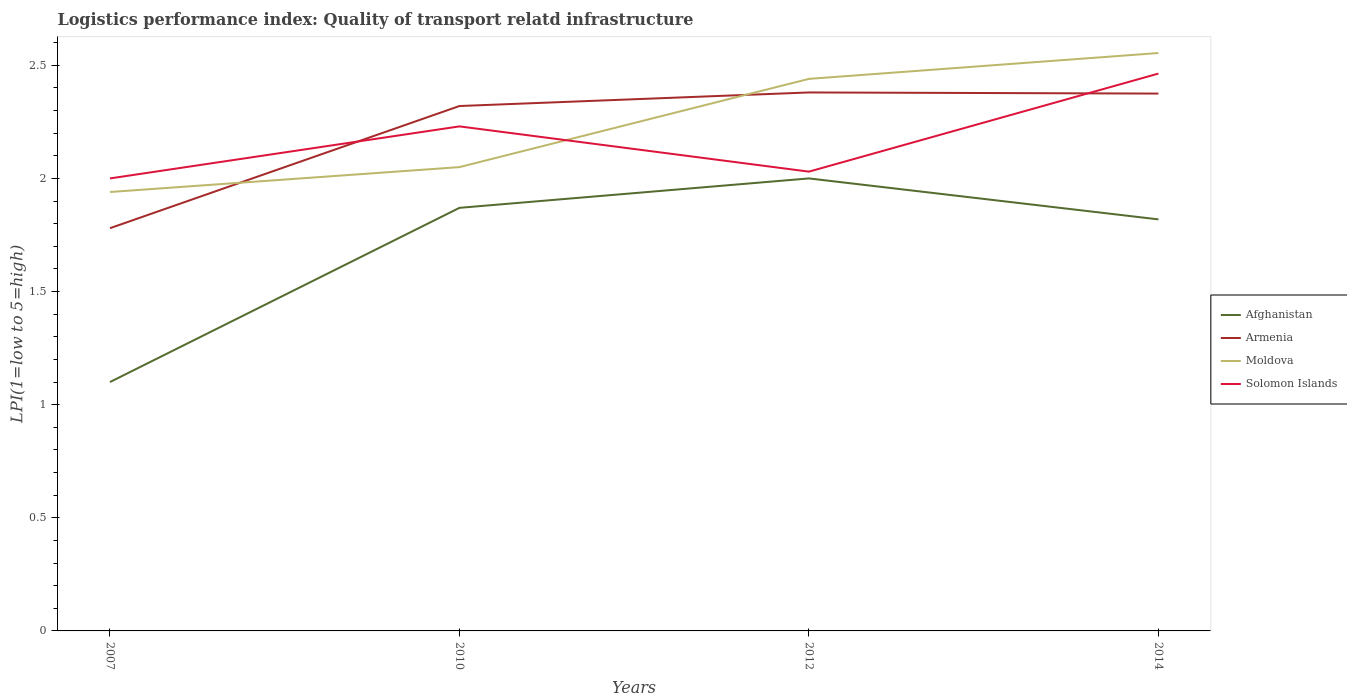Does the line corresponding to Armenia intersect with the line corresponding to Solomon Islands?
Your answer should be compact. Yes. Is the number of lines equal to the number of legend labels?
Give a very brief answer. Yes. In which year was the logistics performance index in Solomon Islands maximum?
Make the answer very short. 2007. What is the total logistics performance index in Moldova in the graph?
Your answer should be compact. -0.5. What is the difference between the highest and the second highest logistics performance index in Armenia?
Provide a succinct answer. 0.6. Is the logistics performance index in Armenia strictly greater than the logistics performance index in Afghanistan over the years?
Your answer should be very brief. No. How many lines are there?
Make the answer very short. 4. What is the difference between two consecutive major ticks on the Y-axis?
Offer a terse response. 0.5. Does the graph contain any zero values?
Give a very brief answer. No. Does the graph contain grids?
Ensure brevity in your answer.  No. Where does the legend appear in the graph?
Offer a terse response. Center right. How many legend labels are there?
Provide a short and direct response. 4. What is the title of the graph?
Offer a very short reply. Logistics performance index: Quality of transport relatd infrastructure. What is the label or title of the X-axis?
Your response must be concise. Years. What is the label or title of the Y-axis?
Make the answer very short. LPI(1=low to 5=high). What is the LPI(1=low to 5=high) of Afghanistan in 2007?
Make the answer very short. 1.1. What is the LPI(1=low to 5=high) in Armenia in 2007?
Your answer should be compact. 1.78. What is the LPI(1=low to 5=high) in Moldova in 2007?
Offer a terse response. 1.94. What is the LPI(1=low to 5=high) in Solomon Islands in 2007?
Your response must be concise. 2. What is the LPI(1=low to 5=high) in Afghanistan in 2010?
Provide a short and direct response. 1.87. What is the LPI(1=low to 5=high) in Armenia in 2010?
Your answer should be compact. 2.32. What is the LPI(1=low to 5=high) in Moldova in 2010?
Give a very brief answer. 2.05. What is the LPI(1=low to 5=high) of Solomon Islands in 2010?
Your answer should be very brief. 2.23. What is the LPI(1=low to 5=high) of Armenia in 2012?
Give a very brief answer. 2.38. What is the LPI(1=low to 5=high) of Moldova in 2012?
Ensure brevity in your answer.  2.44. What is the LPI(1=low to 5=high) of Solomon Islands in 2012?
Provide a short and direct response. 2.03. What is the LPI(1=low to 5=high) of Afghanistan in 2014?
Provide a short and direct response. 1.82. What is the LPI(1=low to 5=high) in Armenia in 2014?
Your answer should be compact. 2.38. What is the LPI(1=low to 5=high) in Moldova in 2014?
Offer a terse response. 2.55. What is the LPI(1=low to 5=high) of Solomon Islands in 2014?
Give a very brief answer. 2.46. Across all years, what is the maximum LPI(1=low to 5=high) of Afghanistan?
Make the answer very short. 2. Across all years, what is the maximum LPI(1=low to 5=high) of Armenia?
Provide a succinct answer. 2.38. Across all years, what is the maximum LPI(1=low to 5=high) of Moldova?
Your answer should be compact. 2.55. Across all years, what is the maximum LPI(1=low to 5=high) of Solomon Islands?
Provide a short and direct response. 2.46. Across all years, what is the minimum LPI(1=low to 5=high) of Afghanistan?
Provide a short and direct response. 1.1. Across all years, what is the minimum LPI(1=low to 5=high) in Armenia?
Offer a terse response. 1.78. Across all years, what is the minimum LPI(1=low to 5=high) of Moldova?
Your answer should be compact. 1.94. Across all years, what is the minimum LPI(1=low to 5=high) of Solomon Islands?
Give a very brief answer. 2. What is the total LPI(1=low to 5=high) of Afghanistan in the graph?
Provide a short and direct response. 6.79. What is the total LPI(1=low to 5=high) of Armenia in the graph?
Offer a terse response. 8.86. What is the total LPI(1=low to 5=high) of Moldova in the graph?
Keep it short and to the point. 8.98. What is the total LPI(1=low to 5=high) of Solomon Islands in the graph?
Offer a terse response. 8.72. What is the difference between the LPI(1=low to 5=high) of Afghanistan in 2007 and that in 2010?
Make the answer very short. -0.77. What is the difference between the LPI(1=low to 5=high) of Armenia in 2007 and that in 2010?
Offer a terse response. -0.54. What is the difference between the LPI(1=low to 5=high) in Moldova in 2007 and that in 2010?
Provide a succinct answer. -0.11. What is the difference between the LPI(1=low to 5=high) in Solomon Islands in 2007 and that in 2010?
Offer a terse response. -0.23. What is the difference between the LPI(1=low to 5=high) in Afghanistan in 2007 and that in 2012?
Offer a terse response. -0.9. What is the difference between the LPI(1=low to 5=high) of Armenia in 2007 and that in 2012?
Ensure brevity in your answer.  -0.6. What is the difference between the LPI(1=low to 5=high) in Solomon Islands in 2007 and that in 2012?
Provide a succinct answer. -0.03. What is the difference between the LPI(1=low to 5=high) in Afghanistan in 2007 and that in 2014?
Make the answer very short. -0.72. What is the difference between the LPI(1=low to 5=high) of Armenia in 2007 and that in 2014?
Keep it short and to the point. -0.59. What is the difference between the LPI(1=low to 5=high) in Moldova in 2007 and that in 2014?
Give a very brief answer. -0.61. What is the difference between the LPI(1=low to 5=high) in Solomon Islands in 2007 and that in 2014?
Provide a succinct answer. -0.46. What is the difference between the LPI(1=low to 5=high) in Afghanistan in 2010 and that in 2012?
Provide a short and direct response. -0.13. What is the difference between the LPI(1=low to 5=high) in Armenia in 2010 and that in 2012?
Your response must be concise. -0.06. What is the difference between the LPI(1=low to 5=high) in Moldova in 2010 and that in 2012?
Give a very brief answer. -0.39. What is the difference between the LPI(1=low to 5=high) in Afghanistan in 2010 and that in 2014?
Offer a very short reply. 0.05. What is the difference between the LPI(1=low to 5=high) in Armenia in 2010 and that in 2014?
Provide a short and direct response. -0.06. What is the difference between the LPI(1=low to 5=high) of Moldova in 2010 and that in 2014?
Keep it short and to the point. -0.5. What is the difference between the LPI(1=low to 5=high) in Solomon Islands in 2010 and that in 2014?
Keep it short and to the point. -0.23. What is the difference between the LPI(1=low to 5=high) in Afghanistan in 2012 and that in 2014?
Your answer should be compact. 0.18. What is the difference between the LPI(1=low to 5=high) of Armenia in 2012 and that in 2014?
Keep it short and to the point. 0.01. What is the difference between the LPI(1=low to 5=high) in Moldova in 2012 and that in 2014?
Provide a succinct answer. -0.11. What is the difference between the LPI(1=low to 5=high) of Solomon Islands in 2012 and that in 2014?
Your answer should be compact. -0.43. What is the difference between the LPI(1=low to 5=high) in Afghanistan in 2007 and the LPI(1=low to 5=high) in Armenia in 2010?
Make the answer very short. -1.22. What is the difference between the LPI(1=low to 5=high) of Afghanistan in 2007 and the LPI(1=low to 5=high) of Moldova in 2010?
Give a very brief answer. -0.95. What is the difference between the LPI(1=low to 5=high) of Afghanistan in 2007 and the LPI(1=low to 5=high) of Solomon Islands in 2010?
Your answer should be compact. -1.13. What is the difference between the LPI(1=low to 5=high) of Armenia in 2007 and the LPI(1=low to 5=high) of Moldova in 2010?
Ensure brevity in your answer.  -0.27. What is the difference between the LPI(1=low to 5=high) in Armenia in 2007 and the LPI(1=low to 5=high) in Solomon Islands in 2010?
Your response must be concise. -0.45. What is the difference between the LPI(1=low to 5=high) in Moldova in 2007 and the LPI(1=low to 5=high) in Solomon Islands in 2010?
Your answer should be very brief. -0.29. What is the difference between the LPI(1=low to 5=high) of Afghanistan in 2007 and the LPI(1=low to 5=high) of Armenia in 2012?
Offer a terse response. -1.28. What is the difference between the LPI(1=low to 5=high) of Afghanistan in 2007 and the LPI(1=low to 5=high) of Moldova in 2012?
Offer a terse response. -1.34. What is the difference between the LPI(1=low to 5=high) in Afghanistan in 2007 and the LPI(1=low to 5=high) in Solomon Islands in 2012?
Offer a very short reply. -0.93. What is the difference between the LPI(1=low to 5=high) in Armenia in 2007 and the LPI(1=low to 5=high) in Moldova in 2012?
Offer a very short reply. -0.66. What is the difference between the LPI(1=low to 5=high) in Moldova in 2007 and the LPI(1=low to 5=high) in Solomon Islands in 2012?
Make the answer very short. -0.09. What is the difference between the LPI(1=low to 5=high) in Afghanistan in 2007 and the LPI(1=low to 5=high) in Armenia in 2014?
Ensure brevity in your answer.  -1.27. What is the difference between the LPI(1=low to 5=high) in Afghanistan in 2007 and the LPI(1=low to 5=high) in Moldova in 2014?
Keep it short and to the point. -1.45. What is the difference between the LPI(1=low to 5=high) in Afghanistan in 2007 and the LPI(1=low to 5=high) in Solomon Islands in 2014?
Offer a terse response. -1.36. What is the difference between the LPI(1=low to 5=high) of Armenia in 2007 and the LPI(1=low to 5=high) of Moldova in 2014?
Offer a terse response. -0.77. What is the difference between the LPI(1=low to 5=high) of Armenia in 2007 and the LPI(1=low to 5=high) of Solomon Islands in 2014?
Your response must be concise. -0.68. What is the difference between the LPI(1=low to 5=high) of Moldova in 2007 and the LPI(1=low to 5=high) of Solomon Islands in 2014?
Provide a succinct answer. -0.52. What is the difference between the LPI(1=low to 5=high) in Afghanistan in 2010 and the LPI(1=low to 5=high) in Armenia in 2012?
Offer a terse response. -0.51. What is the difference between the LPI(1=low to 5=high) of Afghanistan in 2010 and the LPI(1=low to 5=high) of Moldova in 2012?
Your answer should be very brief. -0.57. What is the difference between the LPI(1=low to 5=high) of Afghanistan in 2010 and the LPI(1=low to 5=high) of Solomon Islands in 2012?
Your answer should be compact. -0.16. What is the difference between the LPI(1=low to 5=high) of Armenia in 2010 and the LPI(1=low to 5=high) of Moldova in 2012?
Your answer should be very brief. -0.12. What is the difference between the LPI(1=low to 5=high) in Armenia in 2010 and the LPI(1=low to 5=high) in Solomon Islands in 2012?
Your response must be concise. 0.29. What is the difference between the LPI(1=low to 5=high) in Afghanistan in 2010 and the LPI(1=low to 5=high) in Armenia in 2014?
Make the answer very short. -0.51. What is the difference between the LPI(1=low to 5=high) of Afghanistan in 2010 and the LPI(1=low to 5=high) of Moldova in 2014?
Your answer should be very brief. -0.68. What is the difference between the LPI(1=low to 5=high) of Afghanistan in 2010 and the LPI(1=low to 5=high) of Solomon Islands in 2014?
Offer a terse response. -0.59. What is the difference between the LPI(1=low to 5=high) in Armenia in 2010 and the LPI(1=low to 5=high) in Moldova in 2014?
Your answer should be very brief. -0.23. What is the difference between the LPI(1=low to 5=high) in Armenia in 2010 and the LPI(1=low to 5=high) in Solomon Islands in 2014?
Offer a very short reply. -0.14. What is the difference between the LPI(1=low to 5=high) of Moldova in 2010 and the LPI(1=low to 5=high) of Solomon Islands in 2014?
Offer a very short reply. -0.41. What is the difference between the LPI(1=low to 5=high) in Afghanistan in 2012 and the LPI(1=low to 5=high) in Armenia in 2014?
Give a very brief answer. -0.38. What is the difference between the LPI(1=low to 5=high) of Afghanistan in 2012 and the LPI(1=low to 5=high) of Moldova in 2014?
Offer a terse response. -0.55. What is the difference between the LPI(1=low to 5=high) of Afghanistan in 2012 and the LPI(1=low to 5=high) of Solomon Islands in 2014?
Make the answer very short. -0.46. What is the difference between the LPI(1=low to 5=high) of Armenia in 2012 and the LPI(1=low to 5=high) of Moldova in 2014?
Offer a very short reply. -0.17. What is the difference between the LPI(1=low to 5=high) in Armenia in 2012 and the LPI(1=low to 5=high) in Solomon Islands in 2014?
Your response must be concise. -0.08. What is the difference between the LPI(1=low to 5=high) of Moldova in 2012 and the LPI(1=low to 5=high) of Solomon Islands in 2014?
Your response must be concise. -0.02. What is the average LPI(1=low to 5=high) of Afghanistan per year?
Keep it short and to the point. 1.7. What is the average LPI(1=low to 5=high) of Armenia per year?
Provide a succinct answer. 2.21. What is the average LPI(1=low to 5=high) of Moldova per year?
Give a very brief answer. 2.25. What is the average LPI(1=low to 5=high) of Solomon Islands per year?
Ensure brevity in your answer.  2.18. In the year 2007, what is the difference between the LPI(1=low to 5=high) in Afghanistan and LPI(1=low to 5=high) in Armenia?
Your answer should be compact. -0.68. In the year 2007, what is the difference between the LPI(1=low to 5=high) of Afghanistan and LPI(1=low to 5=high) of Moldova?
Provide a succinct answer. -0.84. In the year 2007, what is the difference between the LPI(1=low to 5=high) of Afghanistan and LPI(1=low to 5=high) of Solomon Islands?
Your answer should be very brief. -0.9. In the year 2007, what is the difference between the LPI(1=low to 5=high) in Armenia and LPI(1=low to 5=high) in Moldova?
Give a very brief answer. -0.16. In the year 2007, what is the difference between the LPI(1=low to 5=high) in Armenia and LPI(1=low to 5=high) in Solomon Islands?
Your response must be concise. -0.22. In the year 2007, what is the difference between the LPI(1=low to 5=high) of Moldova and LPI(1=low to 5=high) of Solomon Islands?
Provide a succinct answer. -0.06. In the year 2010, what is the difference between the LPI(1=low to 5=high) in Afghanistan and LPI(1=low to 5=high) in Armenia?
Your response must be concise. -0.45. In the year 2010, what is the difference between the LPI(1=low to 5=high) in Afghanistan and LPI(1=low to 5=high) in Moldova?
Give a very brief answer. -0.18. In the year 2010, what is the difference between the LPI(1=low to 5=high) in Afghanistan and LPI(1=low to 5=high) in Solomon Islands?
Provide a succinct answer. -0.36. In the year 2010, what is the difference between the LPI(1=low to 5=high) in Armenia and LPI(1=low to 5=high) in Moldova?
Ensure brevity in your answer.  0.27. In the year 2010, what is the difference between the LPI(1=low to 5=high) of Armenia and LPI(1=low to 5=high) of Solomon Islands?
Give a very brief answer. 0.09. In the year 2010, what is the difference between the LPI(1=low to 5=high) in Moldova and LPI(1=low to 5=high) in Solomon Islands?
Offer a very short reply. -0.18. In the year 2012, what is the difference between the LPI(1=low to 5=high) in Afghanistan and LPI(1=low to 5=high) in Armenia?
Give a very brief answer. -0.38. In the year 2012, what is the difference between the LPI(1=low to 5=high) in Afghanistan and LPI(1=low to 5=high) in Moldova?
Offer a terse response. -0.44. In the year 2012, what is the difference between the LPI(1=low to 5=high) in Afghanistan and LPI(1=low to 5=high) in Solomon Islands?
Your response must be concise. -0.03. In the year 2012, what is the difference between the LPI(1=low to 5=high) of Armenia and LPI(1=low to 5=high) of Moldova?
Offer a terse response. -0.06. In the year 2012, what is the difference between the LPI(1=low to 5=high) of Armenia and LPI(1=low to 5=high) of Solomon Islands?
Your answer should be compact. 0.35. In the year 2012, what is the difference between the LPI(1=low to 5=high) of Moldova and LPI(1=low to 5=high) of Solomon Islands?
Keep it short and to the point. 0.41. In the year 2014, what is the difference between the LPI(1=low to 5=high) in Afghanistan and LPI(1=low to 5=high) in Armenia?
Provide a short and direct response. -0.56. In the year 2014, what is the difference between the LPI(1=low to 5=high) of Afghanistan and LPI(1=low to 5=high) of Moldova?
Your answer should be very brief. -0.74. In the year 2014, what is the difference between the LPI(1=low to 5=high) in Afghanistan and LPI(1=low to 5=high) in Solomon Islands?
Your answer should be very brief. -0.64. In the year 2014, what is the difference between the LPI(1=low to 5=high) in Armenia and LPI(1=low to 5=high) in Moldova?
Make the answer very short. -0.18. In the year 2014, what is the difference between the LPI(1=low to 5=high) in Armenia and LPI(1=low to 5=high) in Solomon Islands?
Your response must be concise. -0.09. In the year 2014, what is the difference between the LPI(1=low to 5=high) in Moldova and LPI(1=low to 5=high) in Solomon Islands?
Your answer should be very brief. 0.09. What is the ratio of the LPI(1=low to 5=high) of Afghanistan in 2007 to that in 2010?
Give a very brief answer. 0.59. What is the ratio of the LPI(1=low to 5=high) in Armenia in 2007 to that in 2010?
Give a very brief answer. 0.77. What is the ratio of the LPI(1=low to 5=high) in Moldova in 2007 to that in 2010?
Give a very brief answer. 0.95. What is the ratio of the LPI(1=low to 5=high) of Solomon Islands in 2007 to that in 2010?
Ensure brevity in your answer.  0.9. What is the ratio of the LPI(1=low to 5=high) in Afghanistan in 2007 to that in 2012?
Your answer should be compact. 0.55. What is the ratio of the LPI(1=low to 5=high) of Armenia in 2007 to that in 2012?
Make the answer very short. 0.75. What is the ratio of the LPI(1=low to 5=high) in Moldova in 2007 to that in 2012?
Ensure brevity in your answer.  0.8. What is the ratio of the LPI(1=low to 5=high) in Solomon Islands in 2007 to that in 2012?
Your response must be concise. 0.99. What is the ratio of the LPI(1=low to 5=high) of Afghanistan in 2007 to that in 2014?
Make the answer very short. 0.6. What is the ratio of the LPI(1=low to 5=high) of Armenia in 2007 to that in 2014?
Your answer should be very brief. 0.75. What is the ratio of the LPI(1=low to 5=high) of Moldova in 2007 to that in 2014?
Offer a terse response. 0.76. What is the ratio of the LPI(1=low to 5=high) of Solomon Islands in 2007 to that in 2014?
Your answer should be very brief. 0.81. What is the ratio of the LPI(1=low to 5=high) in Afghanistan in 2010 to that in 2012?
Provide a succinct answer. 0.94. What is the ratio of the LPI(1=low to 5=high) of Armenia in 2010 to that in 2012?
Provide a short and direct response. 0.97. What is the ratio of the LPI(1=low to 5=high) in Moldova in 2010 to that in 2012?
Your answer should be very brief. 0.84. What is the ratio of the LPI(1=low to 5=high) in Solomon Islands in 2010 to that in 2012?
Ensure brevity in your answer.  1.1. What is the ratio of the LPI(1=low to 5=high) of Afghanistan in 2010 to that in 2014?
Offer a very short reply. 1.03. What is the ratio of the LPI(1=low to 5=high) in Armenia in 2010 to that in 2014?
Provide a succinct answer. 0.98. What is the ratio of the LPI(1=low to 5=high) in Moldova in 2010 to that in 2014?
Your response must be concise. 0.8. What is the ratio of the LPI(1=low to 5=high) in Solomon Islands in 2010 to that in 2014?
Provide a short and direct response. 0.91. What is the ratio of the LPI(1=low to 5=high) of Afghanistan in 2012 to that in 2014?
Make the answer very short. 1.1. What is the ratio of the LPI(1=low to 5=high) in Moldova in 2012 to that in 2014?
Give a very brief answer. 0.96. What is the ratio of the LPI(1=low to 5=high) of Solomon Islands in 2012 to that in 2014?
Ensure brevity in your answer.  0.82. What is the difference between the highest and the second highest LPI(1=low to 5=high) of Afghanistan?
Provide a short and direct response. 0.13. What is the difference between the highest and the second highest LPI(1=low to 5=high) in Armenia?
Give a very brief answer. 0.01. What is the difference between the highest and the second highest LPI(1=low to 5=high) of Moldova?
Your response must be concise. 0.11. What is the difference between the highest and the second highest LPI(1=low to 5=high) in Solomon Islands?
Ensure brevity in your answer.  0.23. What is the difference between the highest and the lowest LPI(1=low to 5=high) of Moldova?
Ensure brevity in your answer.  0.61. What is the difference between the highest and the lowest LPI(1=low to 5=high) of Solomon Islands?
Provide a succinct answer. 0.46. 